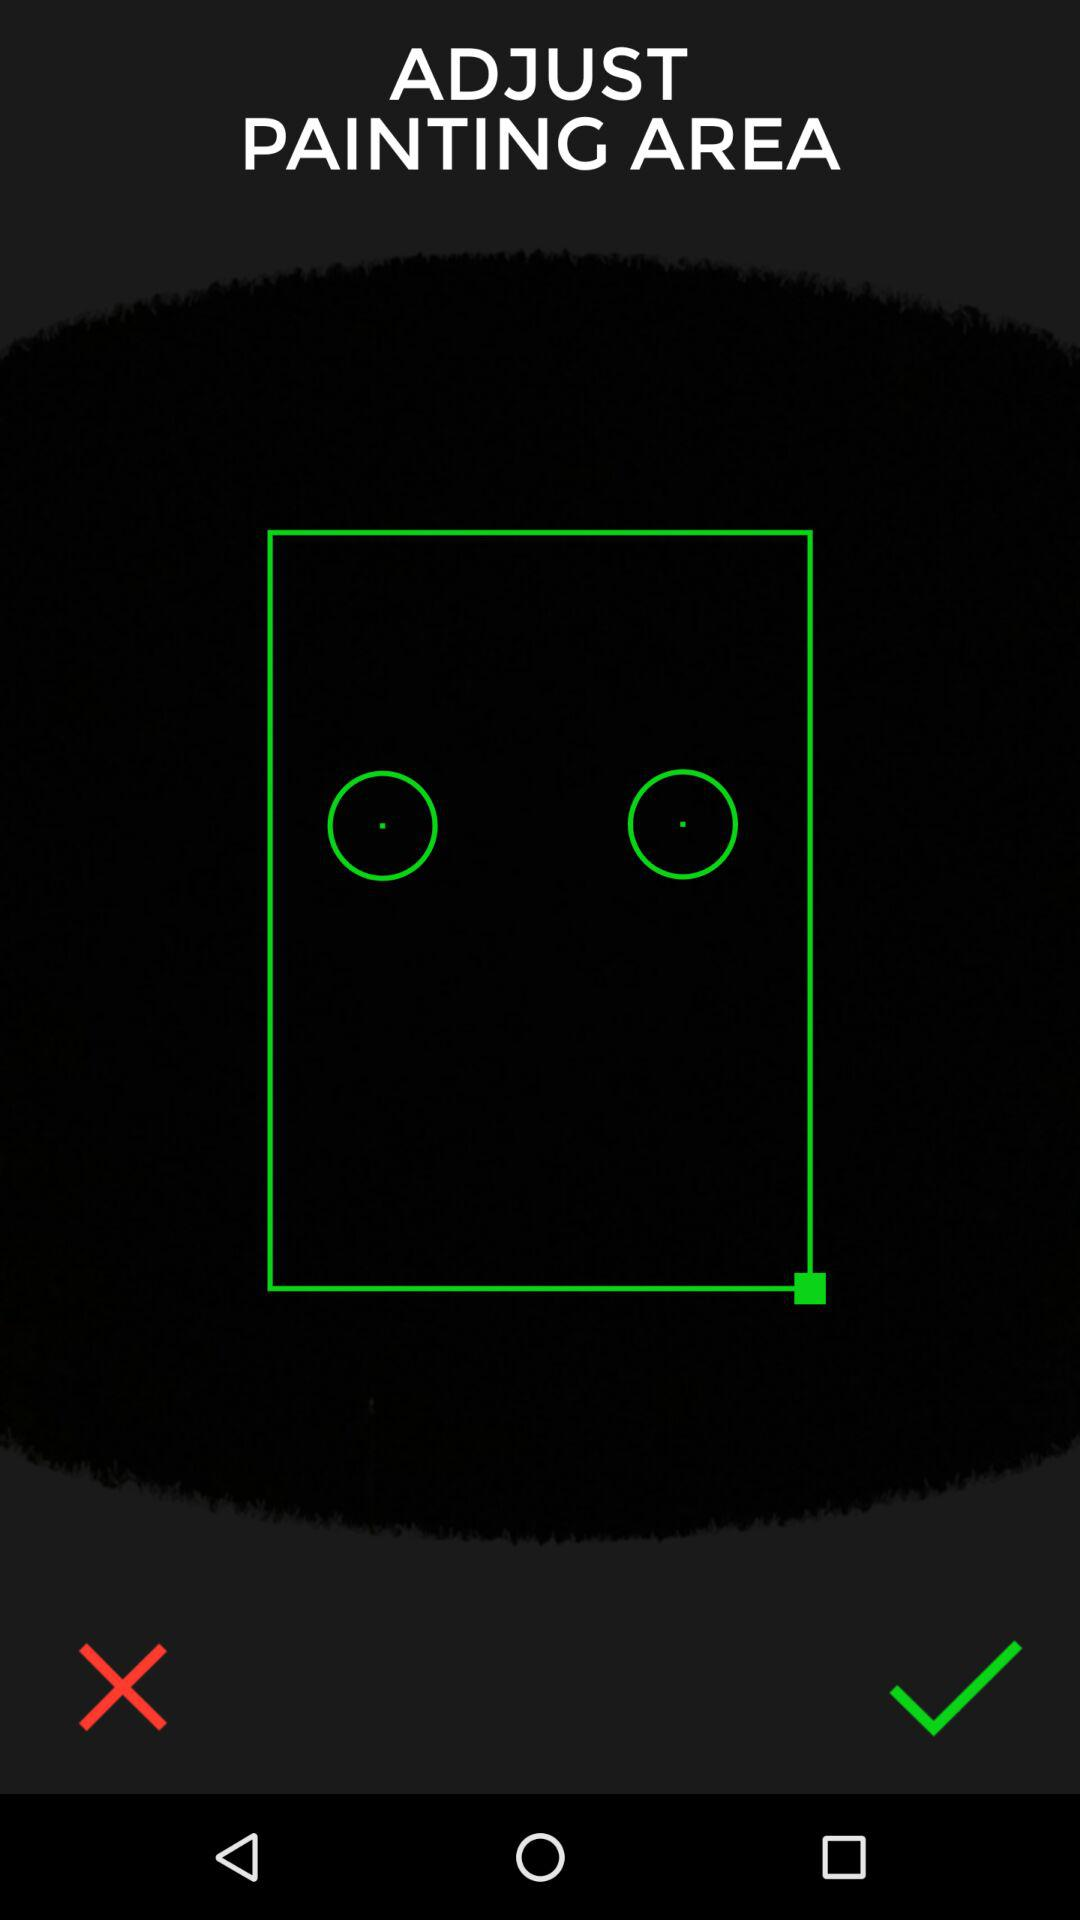How many green circles are on the screen?
Answer the question using a single word or phrase. 2 